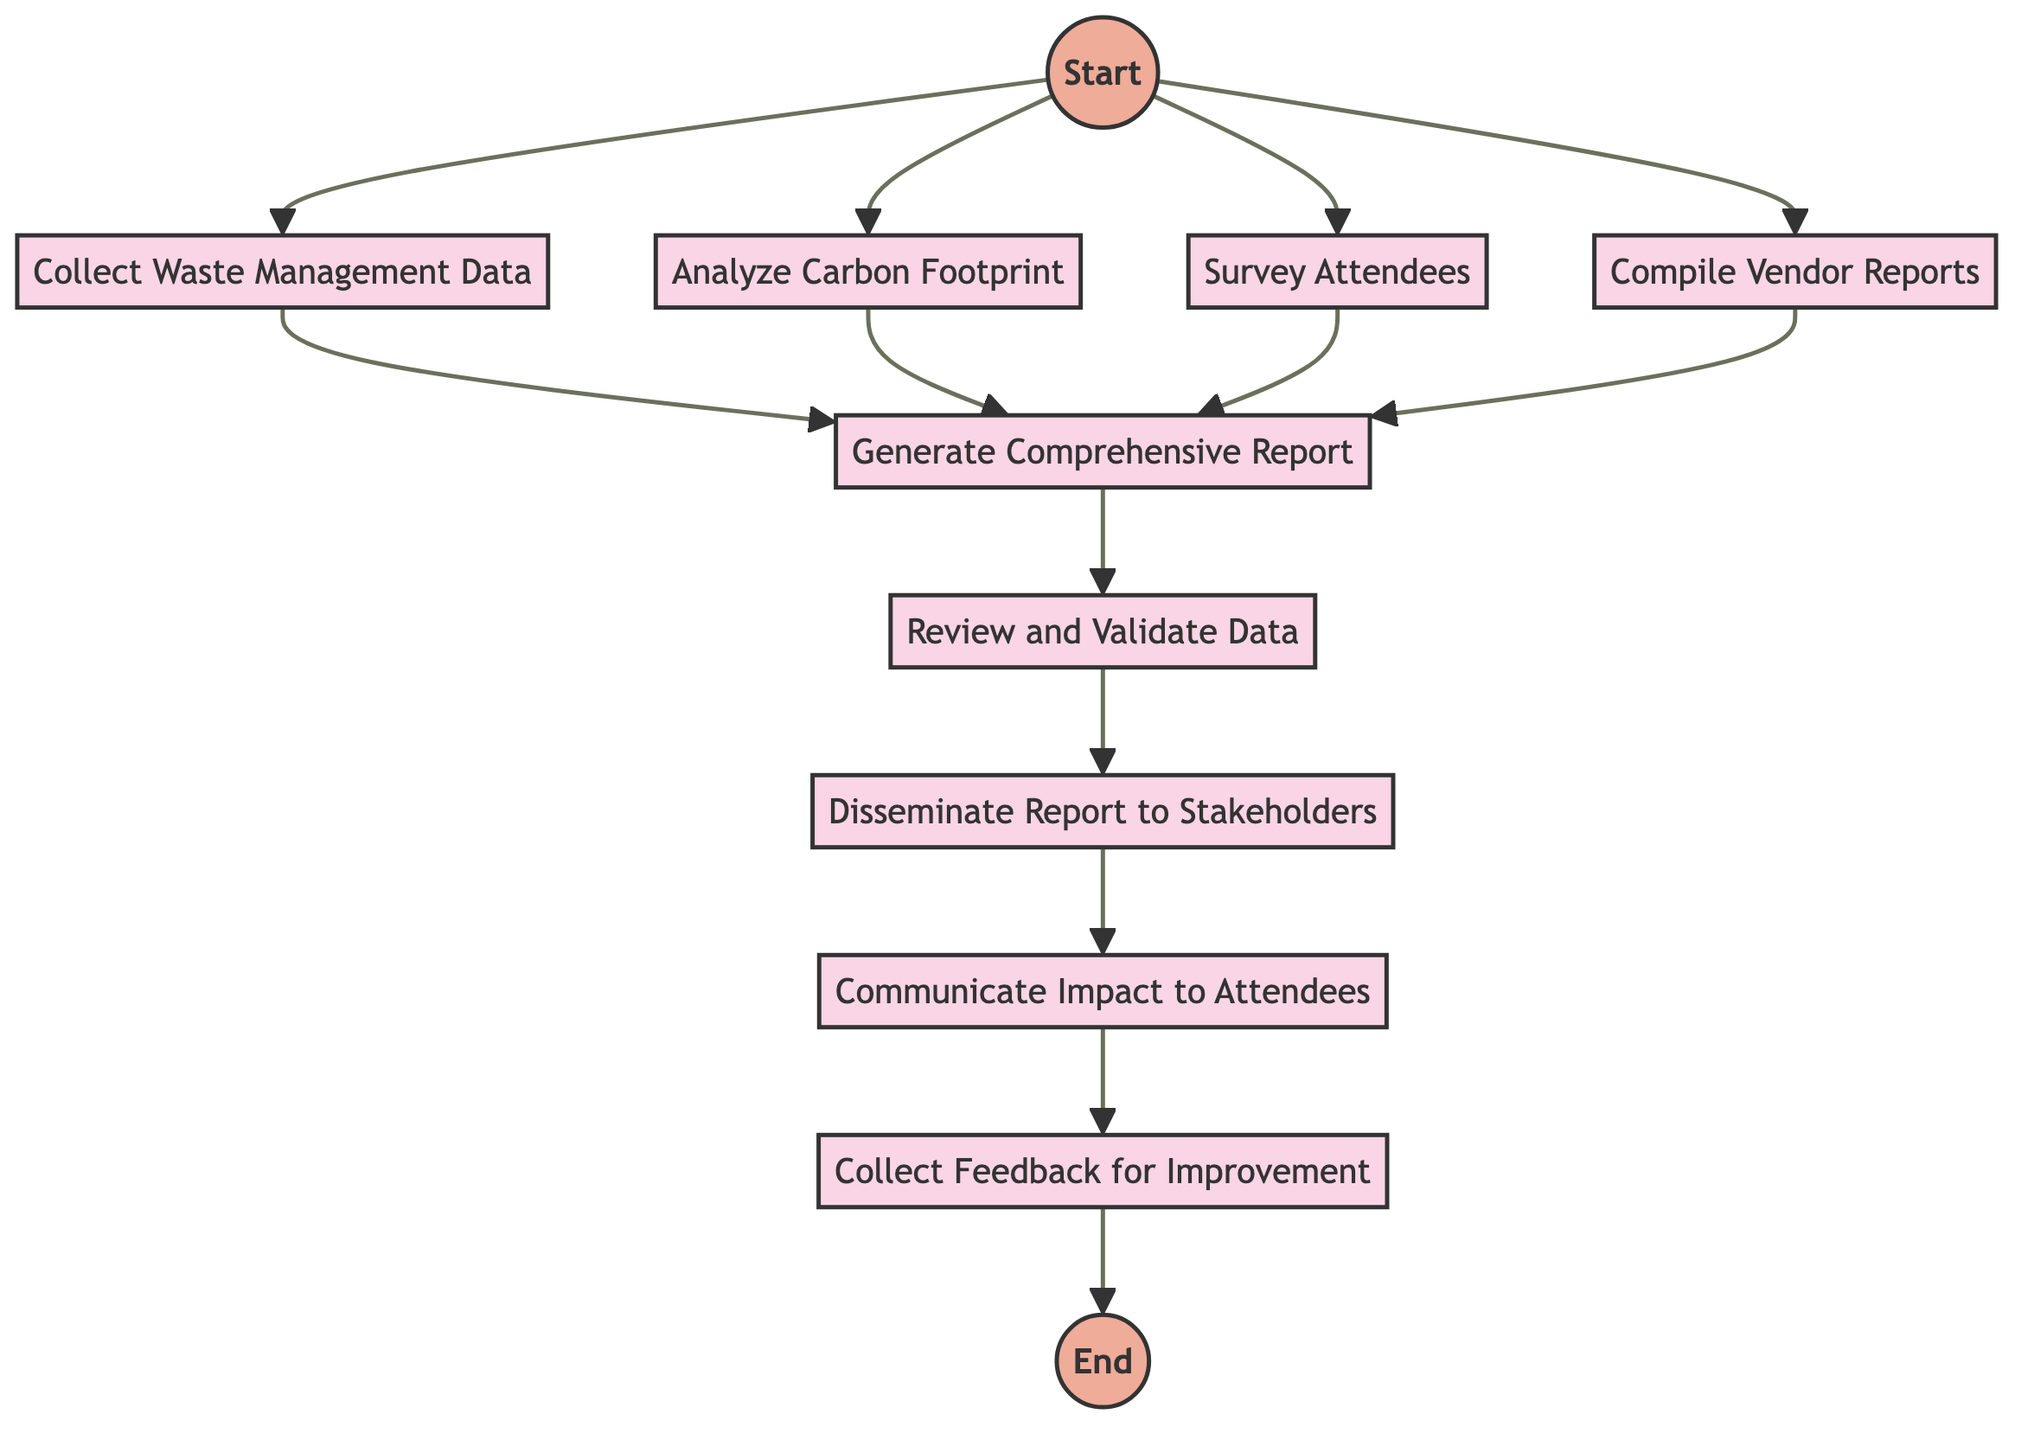What is the first activity in the post-event sustainability reporting process? The first activity in the diagram, which directly follows the Start event, is "Collect Waste Management Data."
Answer: Collect Waste Management Data How many activities are there in total? Counting the activities connected directly after the Start event, there are a total of eight activities present in the diagram.
Answer: Eight What are the last two activities in the process? The last two activities can be found at the end of the flow: "Communicate Impact to Attendees" and "Collect Feedback for Improvement."
Answer: Communicate Impact to Attendees, Collect Feedback for Improvement What activity comes after analyzing the carbon footprint? The activity that follows "Analyze Carbon Footprint" is "Generate Comprehensive Report." This is a direct connection from analyzing to generating the report.
Answer: Generate Comprehensive Report How does feedback collection relate to the overall process? The "Collect Feedback for Improvement" activity is the last step in the process, indicating that stakeholders and attendees' input is essential for future enhancements post-event.
Answer: Last step in the process What activities occur concurrently after the Start? After the Start event, the activities that take place concurrently are "Collect Waste Management Data," "Analyze Carbon Footprint," "Survey Attendees," and "Compile Vendor Reports."
Answer: Four activities Which activity involves stakeholders directly? The activity "Disseminate Report to Stakeholders" directly involves stakeholders as it focuses on sharing the report with them.
Answer: Disseminate Report to Stakeholders What connects the "Review and Validate Data" activity to the report dissemination? "Review and Validate Data" must be completed before "Disseminate Report to Stakeholders," meaning it's a prerequisite activity in the flow.
Answer: It's a prerequisite activity 